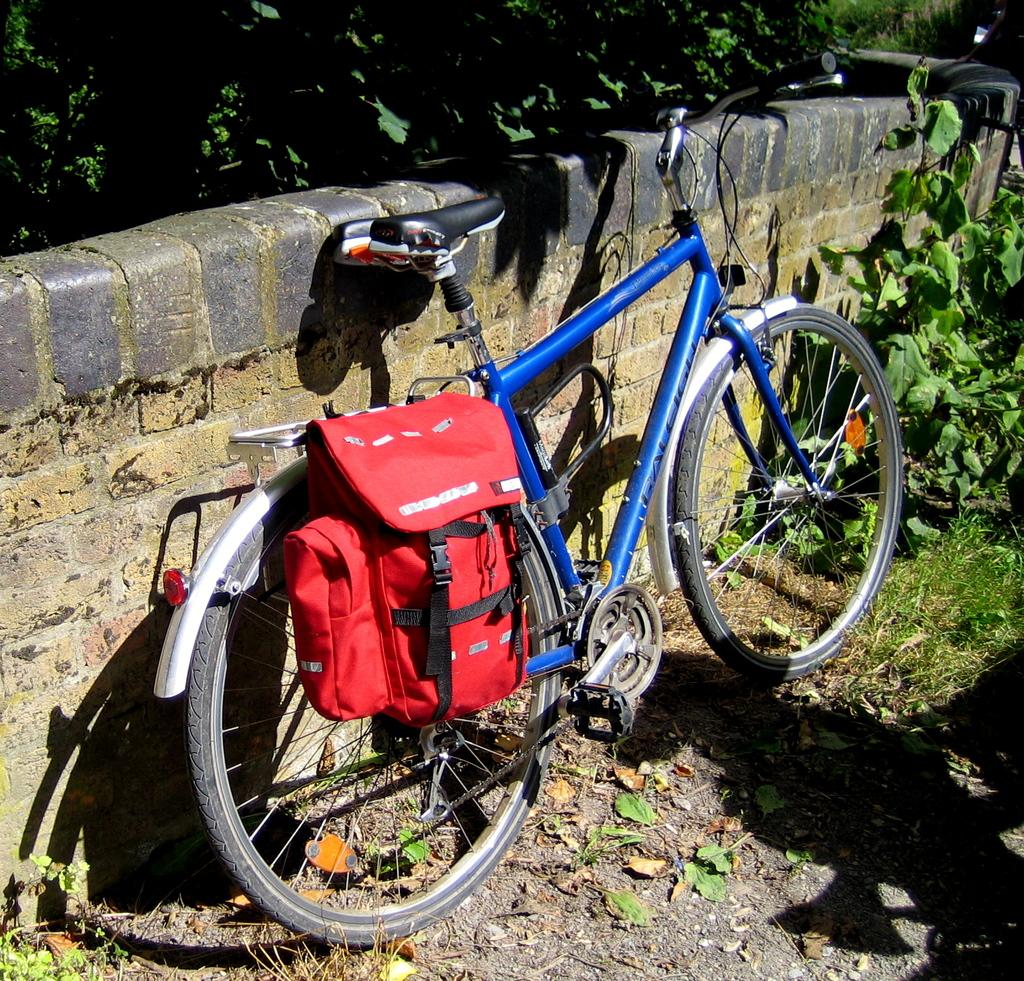What is hanging on the bicycle in the image? There is a bag hanging on a bicycle in the image. What can be seen in the background of the image? There is a wall and trees in the background of the image. What is visible at the bottom of the image? The ground is visible at the bottom of the image. What type of twig is hanging from the wall in the image? There is no twig hanging from the wall in the image. What ornament is placed on the bicycle in the image? There is no ornament present on the bicycle in the image. 